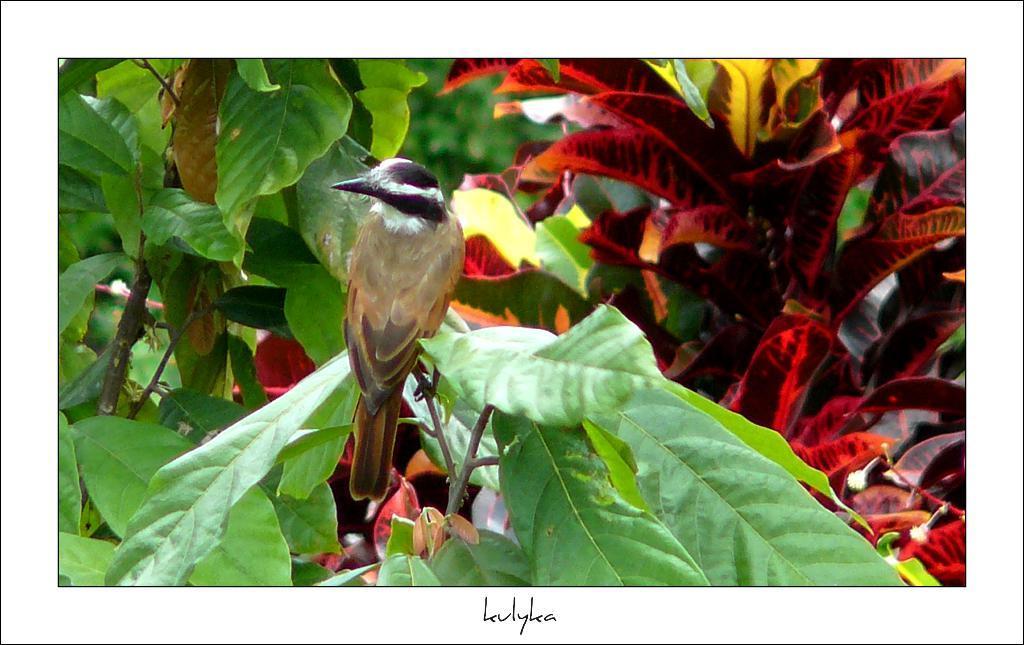In one or two sentences, can you explain what this image depicts? In this image I can see a bird sitting on a plant stem and I can see other plants around. 